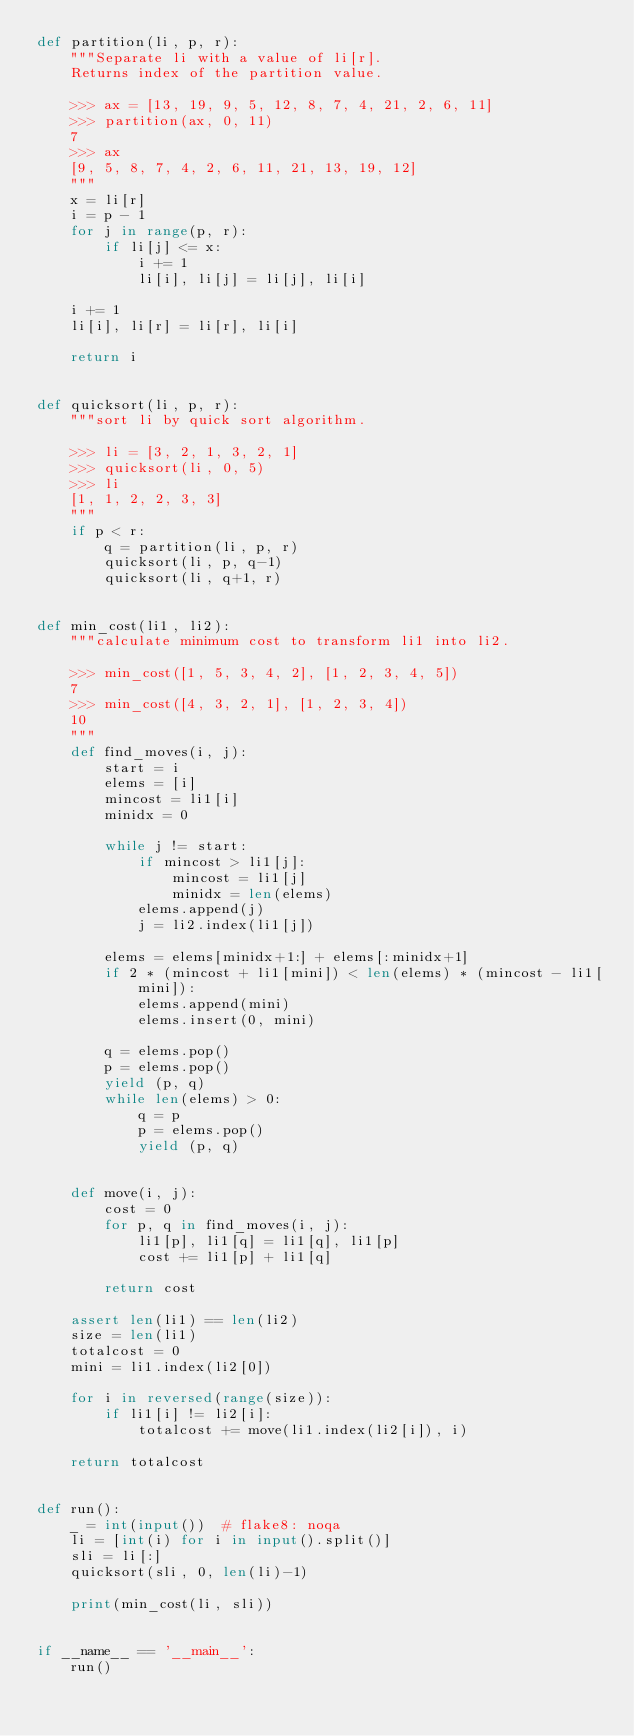Convert code to text. <code><loc_0><loc_0><loc_500><loc_500><_Python_>def partition(li, p, r):
    """Separate li with a value of li[r].
    Returns index of the partition value.

    >>> ax = [13, 19, 9, 5, 12, 8, 7, 4, 21, 2, 6, 11]
    >>> partition(ax, 0, 11)
    7
    >>> ax
    [9, 5, 8, 7, 4, 2, 6, 11, 21, 13, 19, 12]
    """
    x = li[r]
    i = p - 1
    for j in range(p, r):
        if li[j] <= x:
            i += 1
            li[i], li[j] = li[j], li[i]

    i += 1
    li[i], li[r] = li[r], li[i]

    return i


def quicksort(li, p, r):
    """sort li by quick sort algorithm.

    >>> li = [3, 2, 1, 3, 2, 1]
    >>> quicksort(li, 0, 5)
    >>> li
    [1, 1, 2, 2, 3, 3]
    """
    if p < r:
        q = partition(li, p, r)
        quicksort(li, p, q-1)
        quicksort(li, q+1, r)


def min_cost(li1, li2):
    """calculate minimum cost to transform li1 into li2.

    >>> min_cost([1, 5, 3, 4, 2], [1, 2, 3, 4, 5])
    7
    >>> min_cost([4, 3, 2, 1], [1, 2, 3, 4])
    10
    """
    def find_moves(i, j):
        start = i
        elems = [i]
        mincost = li1[i]
        minidx = 0

        while j != start:
            if mincost > li1[j]:
                mincost = li1[j]
                minidx = len(elems)
            elems.append(j)
            j = li2.index(li1[j])

        elems = elems[minidx+1:] + elems[:minidx+1]
        if 2 * (mincost + li1[mini]) < len(elems) * (mincost - li1[mini]):
            elems.append(mini)
            elems.insert(0, mini)

        q = elems.pop()
        p = elems.pop()
        yield (p, q)
        while len(elems) > 0:
            q = p
            p = elems.pop()
            yield (p, q)


    def move(i, j):
        cost = 0
        for p, q in find_moves(i, j):
            li1[p], li1[q] = li1[q], li1[p]
            cost += li1[p] + li1[q]

        return cost

    assert len(li1) == len(li2)
    size = len(li1)
    totalcost = 0
    mini = li1.index(li2[0])

    for i in reversed(range(size)):
        if li1[i] != li2[i]:
            totalcost += move(li1.index(li2[i]), i)

    return totalcost


def run():
    _ = int(input())  # flake8: noqa
    li = [int(i) for i in input().split()]
    sli = li[:]
    quicksort(sli, 0, len(li)-1)

    print(min_cost(li, sli))


if __name__ == '__main__':
    run()

</code> 